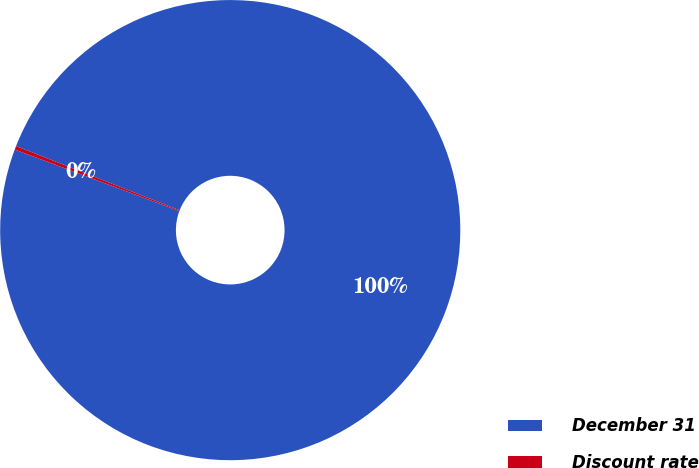<chart> <loc_0><loc_0><loc_500><loc_500><pie_chart><fcel>December 31<fcel>Discount rate<nl><fcel>99.74%<fcel>0.26%<nl></chart> 